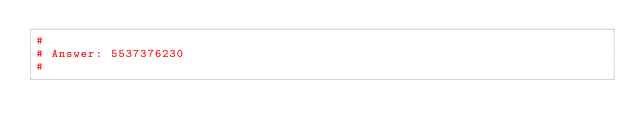<code> <loc_0><loc_0><loc_500><loc_500><_Python_>#
# Answer: 5537376230
#
</code> 